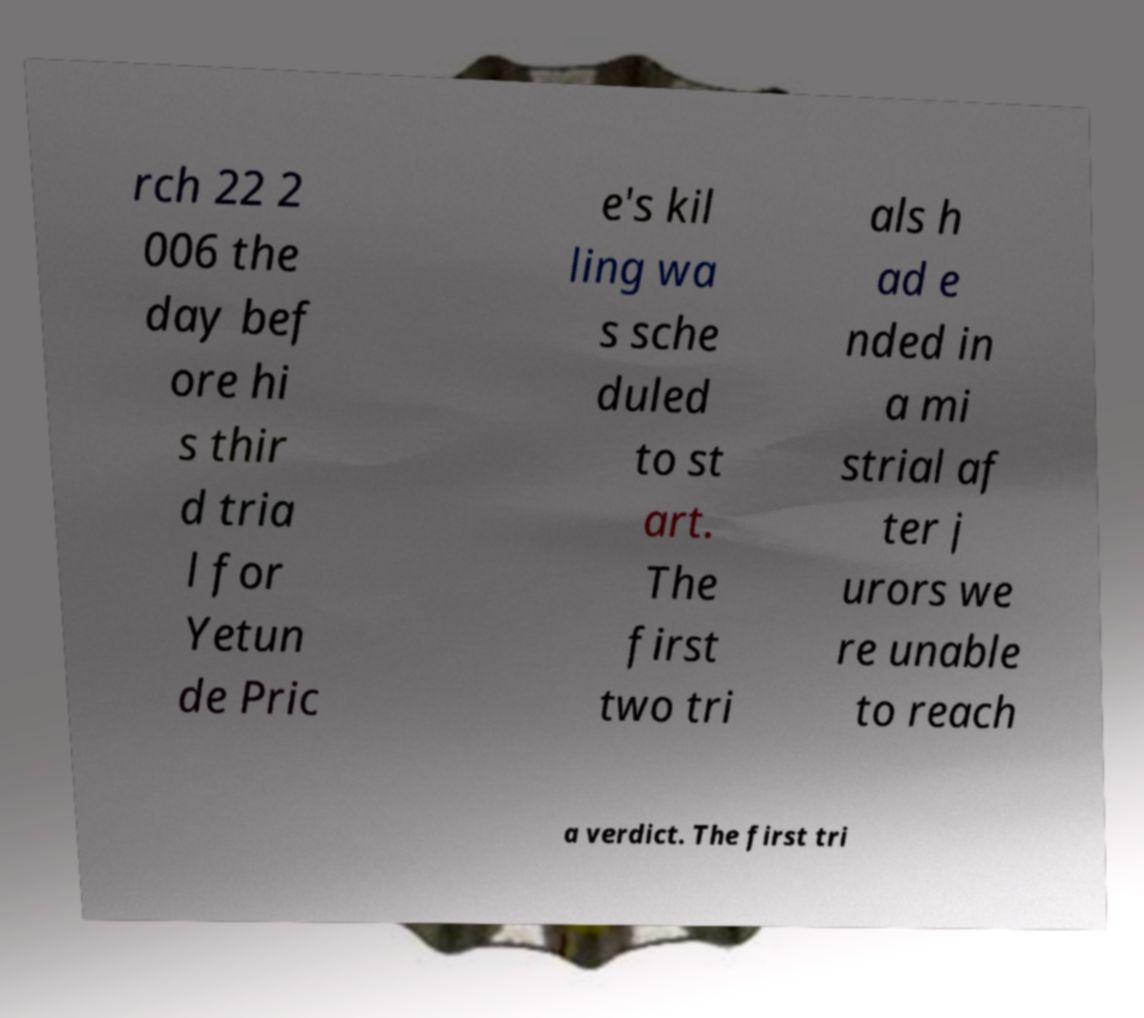What messages or text are displayed in this image? I need them in a readable, typed format. rch 22 2 006 the day bef ore hi s thir d tria l for Yetun de Pric e's kil ling wa s sche duled to st art. The first two tri als h ad e nded in a mi strial af ter j urors we re unable to reach a verdict. The first tri 